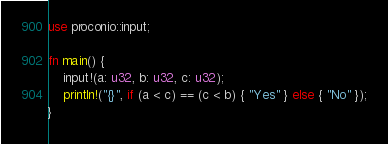<code> <loc_0><loc_0><loc_500><loc_500><_Rust_>use proconio::input;

fn main() {
    input!(a: u32, b: u32, c: u32);
    println!("{}", if (a < c) == (c < b) { "Yes" } else { "No" });
}
</code> 